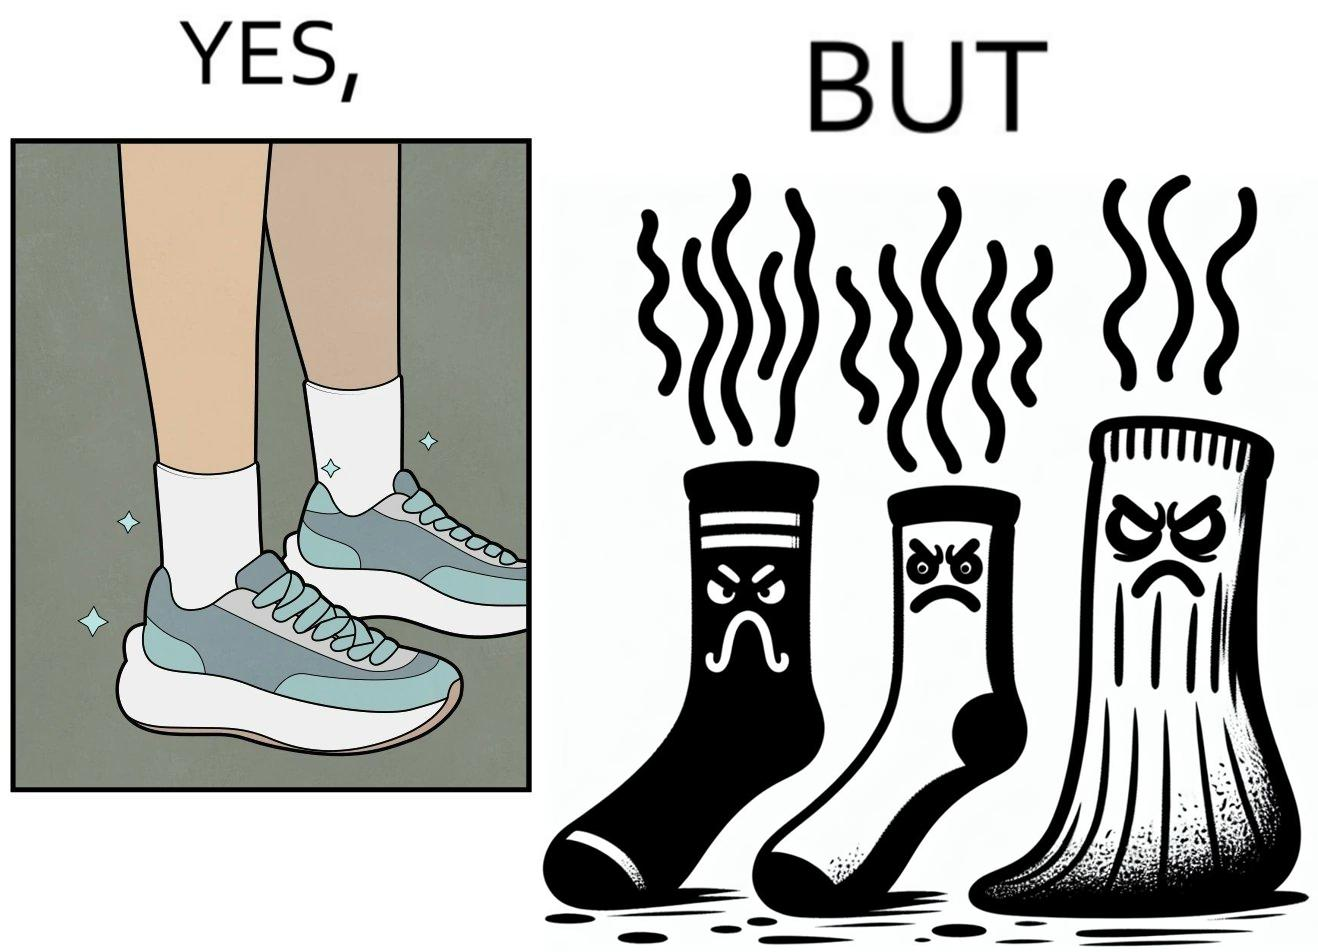Is this image satirical or non-satirical? Yes, this image is satirical. 